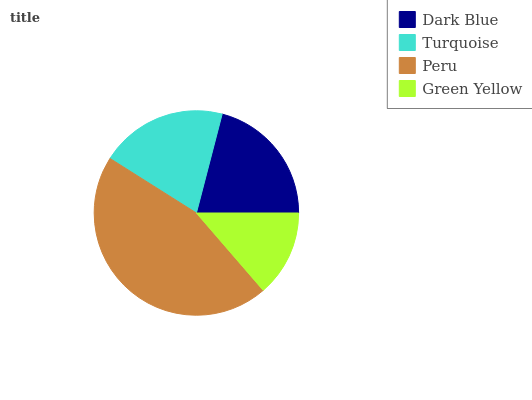Is Green Yellow the minimum?
Answer yes or no. Yes. Is Peru the maximum?
Answer yes or no. Yes. Is Turquoise the minimum?
Answer yes or no. No. Is Turquoise the maximum?
Answer yes or no. No. Is Dark Blue greater than Turquoise?
Answer yes or no. Yes. Is Turquoise less than Dark Blue?
Answer yes or no. Yes. Is Turquoise greater than Dark Blue?
Answer yes or no. No. Is Dark Blue less than Turquoise?
Answer yes or no. No. Is Dark Blue the high median?
Answer yes or no. Yes. Is Turquoise the low median?
Answer yes or no. Yes. Is Green Yellow the high median?
Answer yes or no. No. Is Peru the low median?
Answer yes or no. No. 